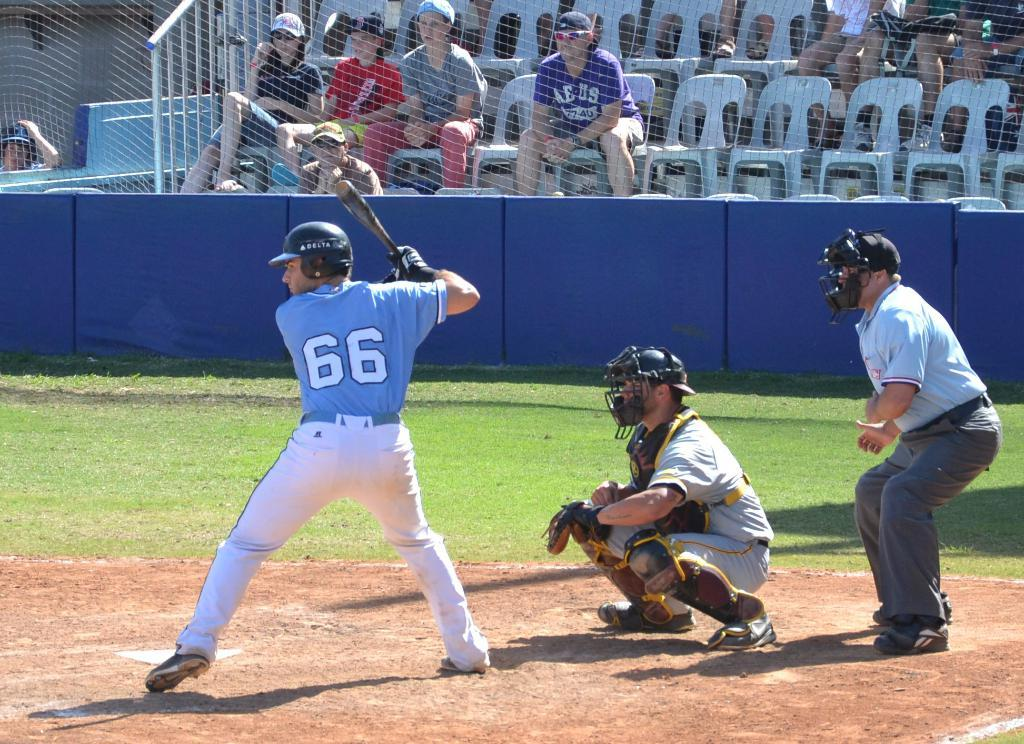<image>
Relay a brief, clear account of the picture shown. A batter at a baseball game getting ready to hit the ball with the number 66 on the back of his jersey. 